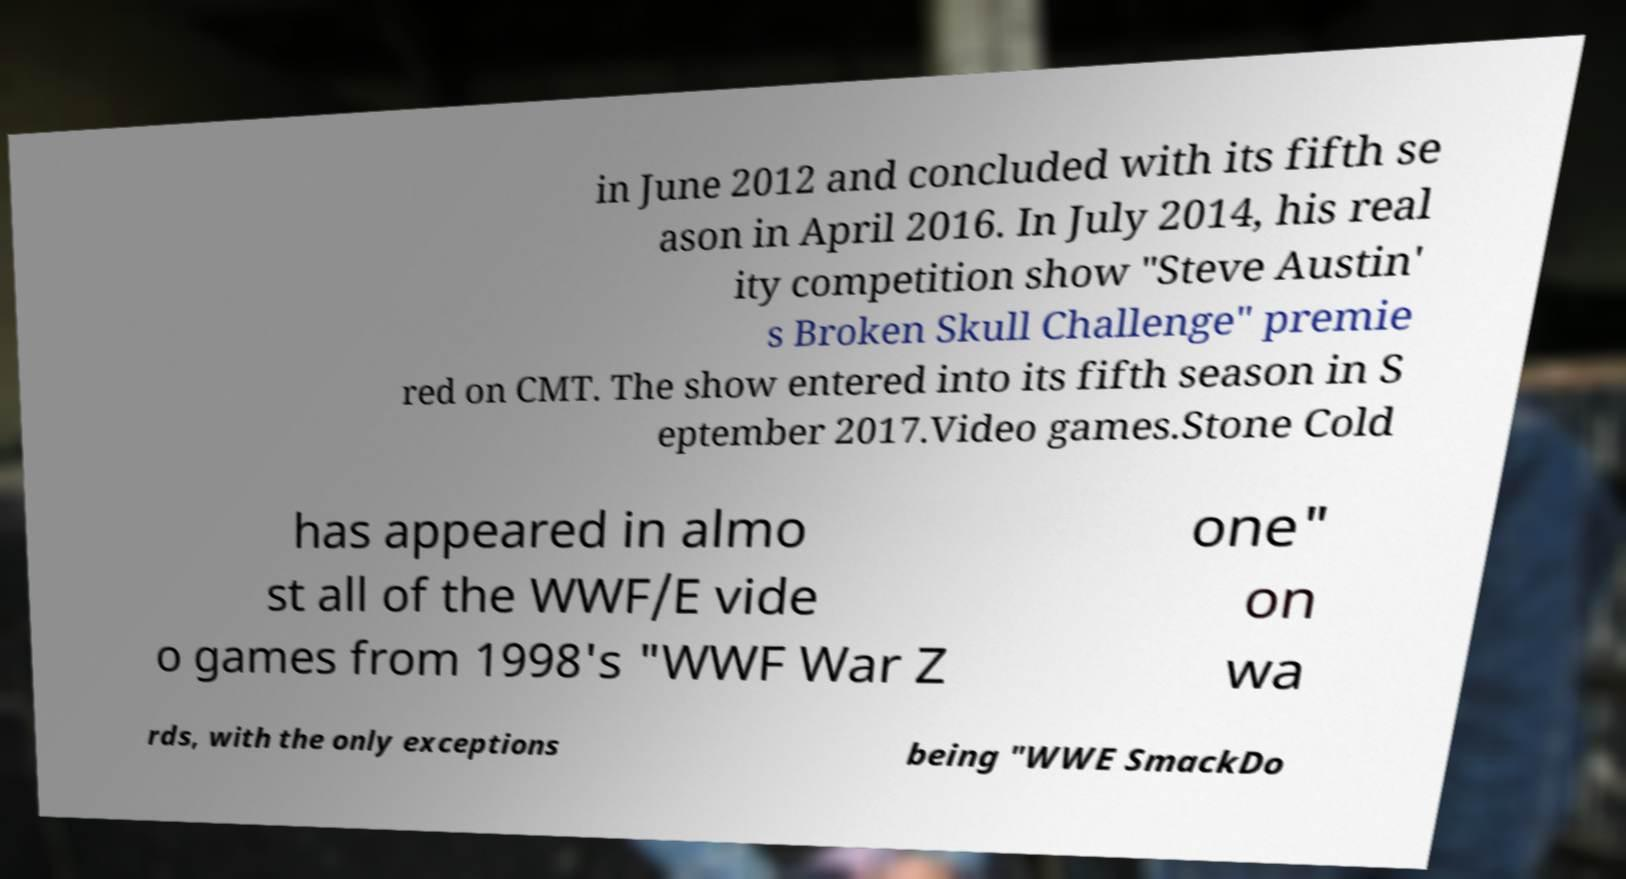For documentation purposes, I need the text within this image transcribed. Could you provide that? in June 2012 and concluded with its fifth se ason in April 2016. In July 2014, his real ity competition show "Steve Austin' s Broken Skull Challenge" premie red on CMT. The show entered into its fifth season in S eptember 2017.Video games.Stone Cold has appeared in almo st all of the WWF/E vide o games from 1998's "WWF War Z one" on wa rds, with the only exceptions being "WWE SmackDo 